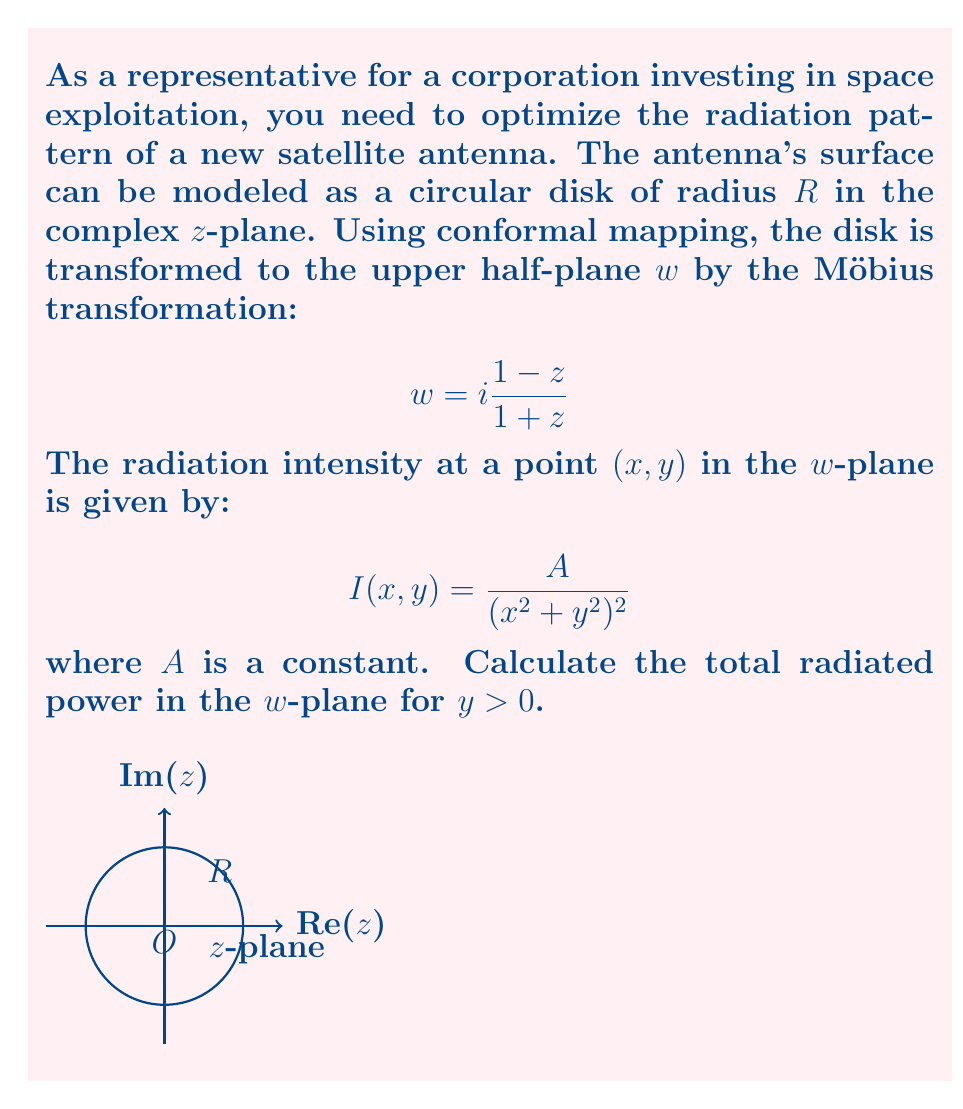Solve this math problem. Let's approach this step-by-step:

1) First, we need to set up the integral for the total radiated power in the $w$-plane:

   $$P = \int_{-\infty}^{\infty}\int_{0}^{\infty} I(x,y) \,dy\,dx = A\int_{-\infty}^{\infty}\int_{0}^{\infty} \frac{1}{(x^2+y^2)^2} \,dy\,dx$$

2) To solve this, we can use polar coordinates. Let $x = r\cos\theta$ and $y = r\sin\theta$. The Jacobian of this transformation is $r$. The limits change:
   $r: 0 \to \infty$, $\theta: 0 \to \pi$

   $$P = A\int_{0}^{\pi}\int_{0}^{\infty} \frac{r}{r^4} \,dr\,d\theta = A\int_{0}^{\pi}\int_{0}^{\infty} \frac{1}{r^3} \,dr\,d\theta$$

3) Solving the inner integral:

   $$\int_{0}^{\infty} \frac{1}{r^3} \,dr = \left[-\frac{1}{2r^2}\right]_{0}^{\infty} = \frac{1}{2\cdot 0^2} - 0 = \infty$$

4) Therefore, the total radiated power in the $w$-plane is:

   $$P = A\int_{0}^{\pi} \infty \,d\theta = \infty$$

5) This result makes physical sense because we're integrating over an infinite plane, and the intensity falls off as the fourth power of distance, which is not fast enough to make the integral converge.

6) In practice, we would need to introduce a cutoff distance or use a more realistic antenna model that takes into account the finite size of the original disk in the $z$-plane.
Answer: $P = \infty$ 